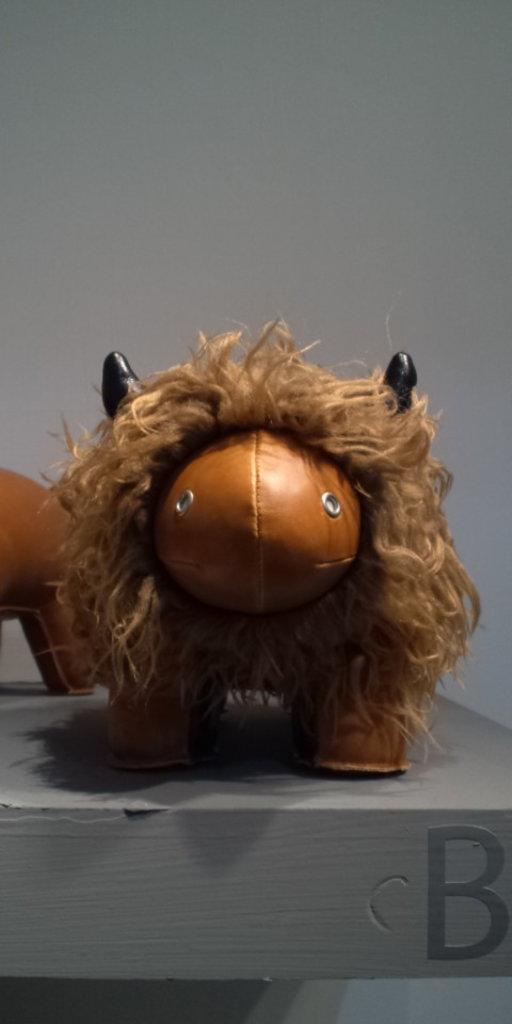In one or two sentences, can you explain what this image depicts? In this picture we can see there are two toys on an object. Behind the toys there's a wall. On the object, it is written as "B". 